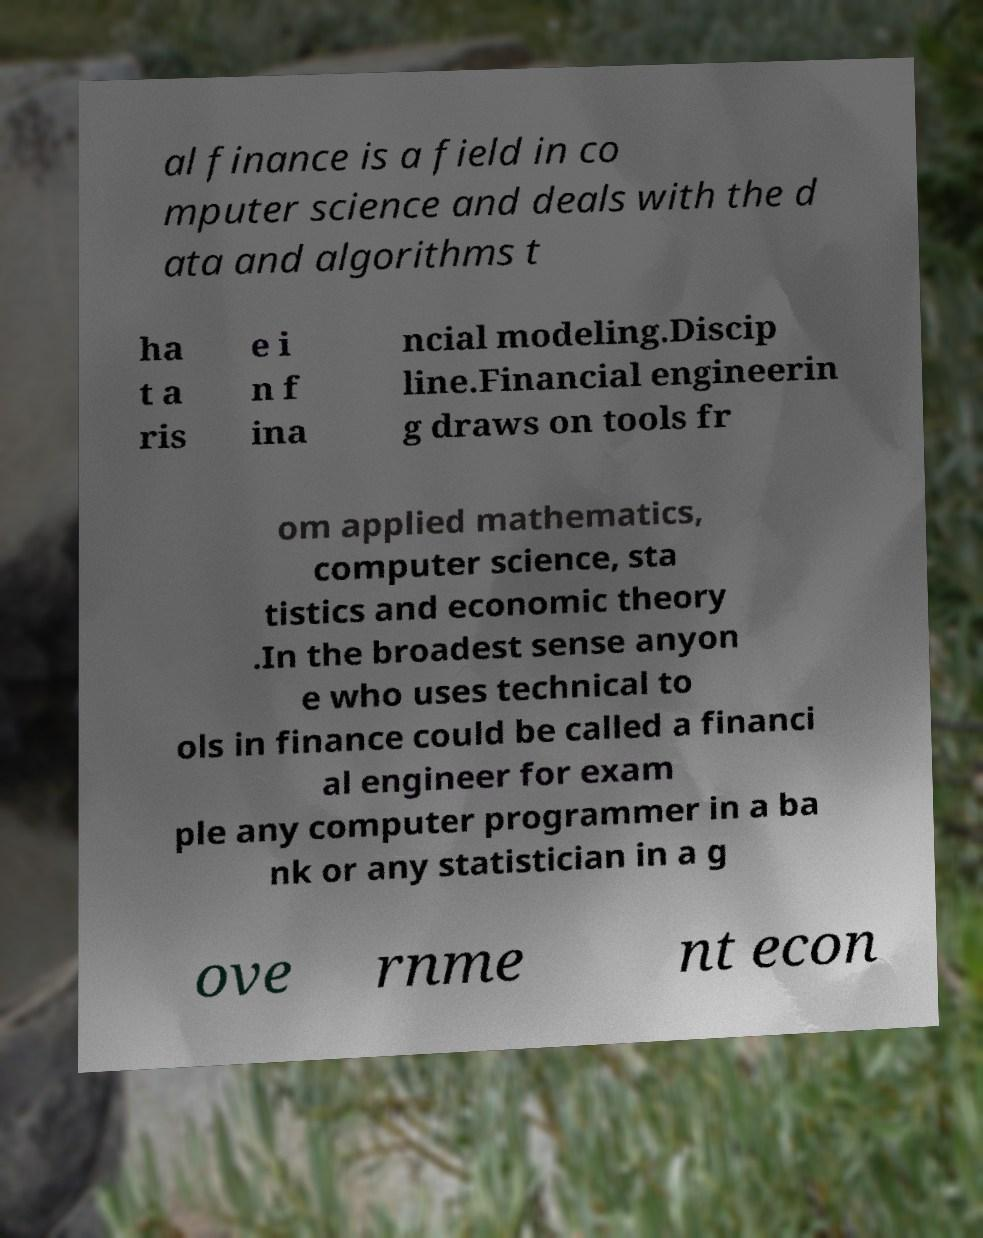There's text embedded in this image that I need extracted. Can you transcribe it verbatim? al finance is a field in co mputer science and deals with the d ata and algorithms t ha t a ris e i n f ina ncial modeling.Discip line.Financial engineerin g draws on tools fr om applied mathematics, computer science, sta tistics and economic theory .In the broadest sense anyon e who uses technical to ols in finance could be called a financi al engineer for exam ple any computer programmer in a ba nk or any statistician in a g ove rnme nt econ 